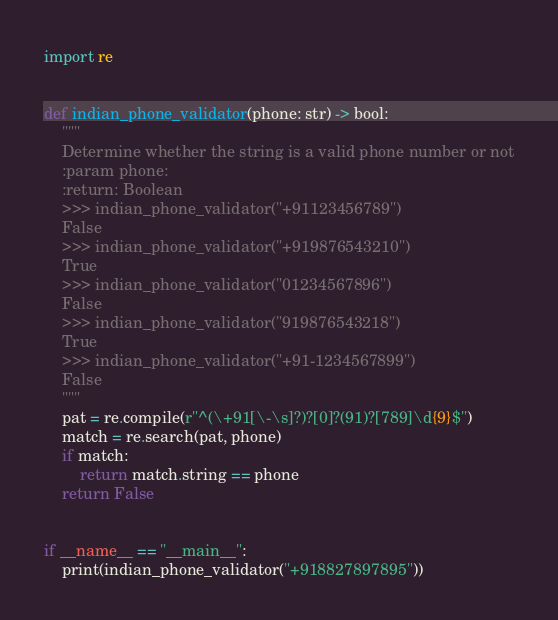Convert code to text. <code><loc_0><loc_0><loc_500><loc_500><_Python_>import re


def indian_phone_validator(phone: str) -> bool:
    """
    Determine whether the string is a valid phone number or not
    :param phone:
    :return: Boolean
    >>> indian_phone_validator("+91123456789")
    False
    >>> indian_phone_validator("+919876543210")
    True
    >>> indian_phone_validator("01234567896")
    False
    >>> indian_phone_validator("919876543218")
    True
    >>> indian_phone_validator("+91-1234567899")
    False
    """
    pat = re.compile(r"^(\+91[\-\s]?)?[0]?(91)?[789]\d{9}$")
    match = re.search(pat, phone)
    if match:
        return match.string == phone
    return False


if __name__ == "__main__":
    print(indian_phone_validator("+918827897895"))
</code> 